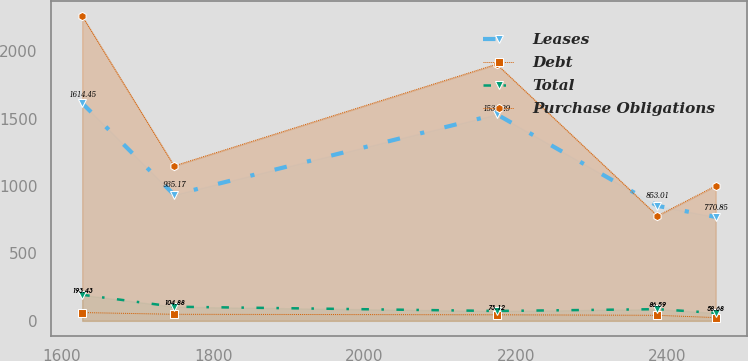Convert chart to OTSL. <chart><loc_0><loc_0><loc_500><loc_500><line_chart><ecel><fcel>Leases<fcel>Debt<fcel>Total<fcel>Purchase Obligations<nl><fcel>1626.57<fcel>1614.45<fcel>61.6<fcel>193.43<fcel>2260.78<nl><fcel>1748.14<fcel>935.17<fcel>48.62<fcel>104.88<fcel>1149.32<nl><fcel>2174.74<fcel>1532.29<fcel>44.87<fcel>73.12<fcel>1904.01<nl><fcel>2387.38<fcel>853.01<fcel>41.12<fcel>86.59<fcel>778.95<nl><fcel>2464.44<fcel>770.85<fcel>24.08<fcel>58.68<fcel>1001.14<nl></chart> 